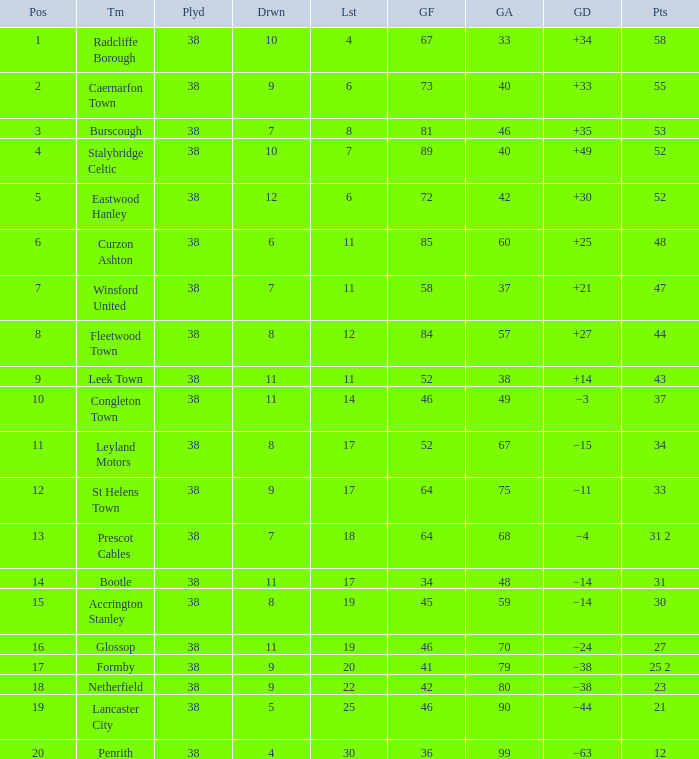WHAT IS THE LOST WITH A DRAWN 11, FOR LEEK TOWN? 11.0. 